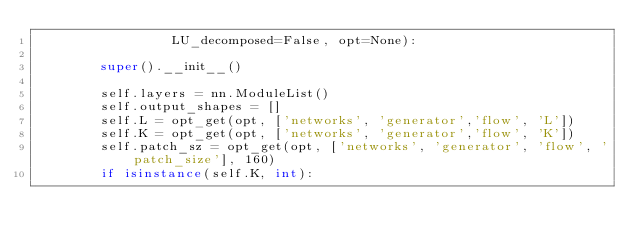Convert code to text. <code><loc_0><loc_0><loc_500><loc_500><_Python_>                 LU_decomposed=False, opt=None):

        super().__init__()

        self.layers = nn.ModuleList()
        self.output_shapes = []
        self.L = opt_get(opt, ['networks', 'generator','flow', 'L'])
        self.K = opt_get(opt, ['networks', 'generator','flow', 'K'])
        self.patch_sz = opt_get(opt, ['networks', 'generator', 'flow', 'patch_size'], 160)
        if isinstance(self.K, int):</code> 